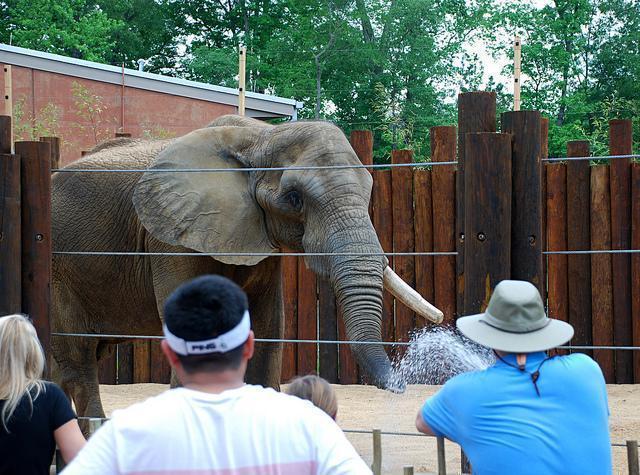What are people watching the elephant likely to use to shoot it?
From the following four choices, select the correct answer to address the question.
Options: Camera, gun, bow/ arrows, darts. Camera. 